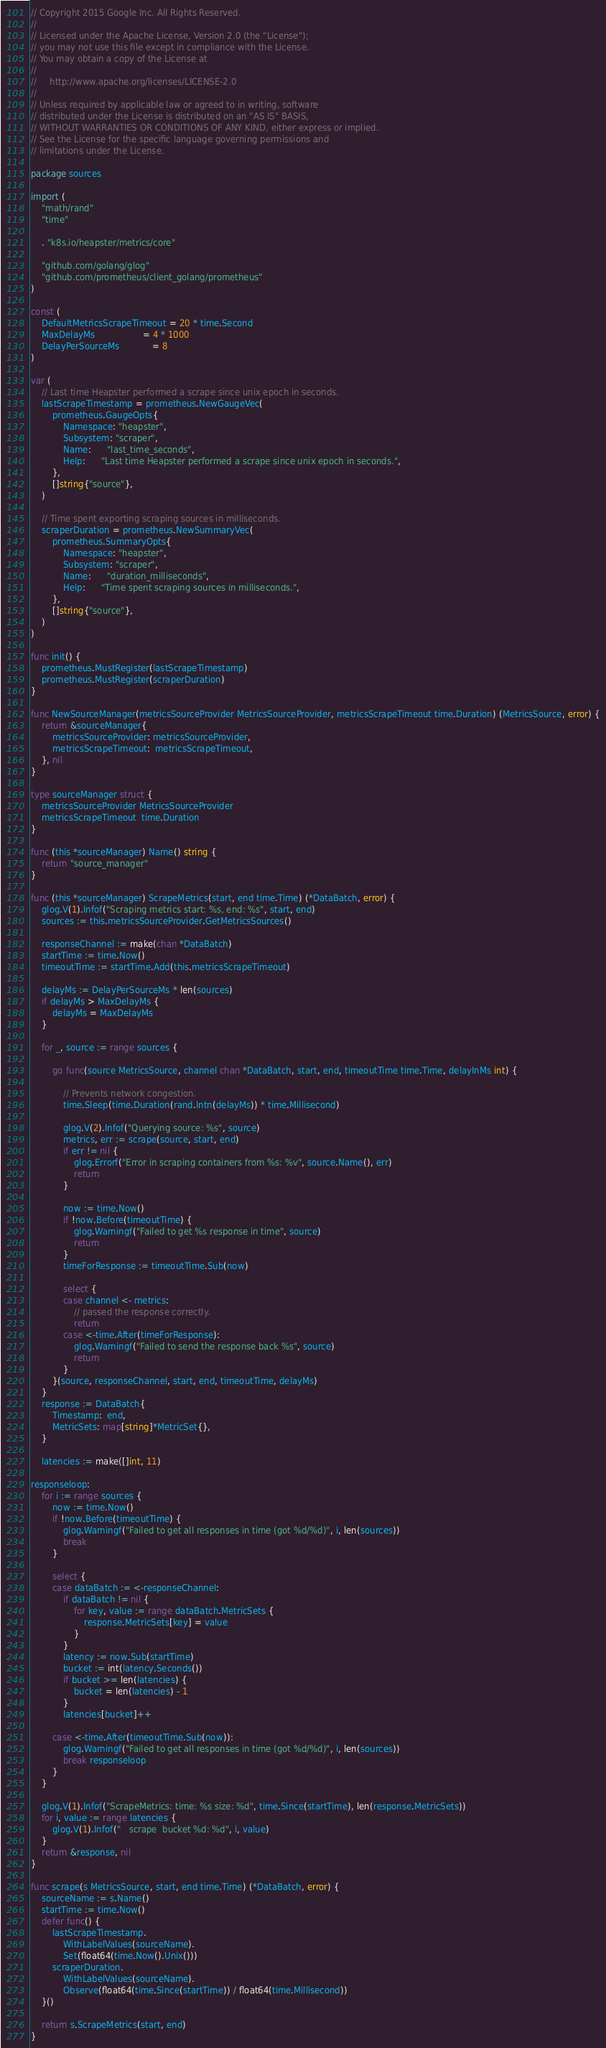Convert code to text. <code><loc_0><loc_0><loc_500><loc_500><_Go_>// Copyright 2015 Google Inc. All Rights Reserved.
//
// Licensed under the Apache License, Version 2.0 (the "License");
// you may not use this file except in compliance with the License.
// You may obtain a copy of the License at
//
//     http://www.apache.org/licenses/LICENSE-2.0
//
// Unless required by applicable law or agreed to in writing, software
// distributed under the License is distributed on an "AS IS" BASIS,
// WITHOUT WARRANTIES OR CONDITIONS OF ANY KIND, either express or implied.
// See the License for the specific language governing permissions and
// limitations under the License.

package sources

import (
	"math/rand"
	"time"

	. "k8s.io/heapster/metrics/core"

	"github.com/golang/glog"
	"github.com/prometheus/client_golang/prometheus"
)

const (
	DefaultMetricsScrapeTimeout = 20 * time.Second
	MaxDelayMs                  = 4 * 1000
	DelayPerSourceMs            = 8
)

var (
	// Last time Heapster performed a scrape since unix epoch in seconds.
	lastScrapeTimestamp = prometheus.NewGaugeVec(
		prometheus.GaugeOpts{
			Namespace: "heapster",
			Subsystem: "scraper",
			Name:      "last_time_seconds",
			Help:      "Last time Heapster performed a scrape since unix epoch in seconds.",
		},
		[]string{"source"},
	)

	// Time spent exporting scraping sources in milliseconds.
	scraperDuration = prometheus.NewSummaryVec(
		prometheus.SummaryOpts{
			Namespace: "heapster",
			Subsystem: "scraper",
			Name:      "duration_milliseconds",
			Help:      "Time spent scraping sources in milliseconds.",
		},
		[]string{"source"},
	)
)

func init() {
	prometheus.MustRegister(lastScrapeTimestamp)
	prometheus.MustRegister(scraperDuration)
}

func NewSourceManager(metricsSourceProvider MetricsSourceProvider, metricsScrapeTimeout time.Duration) (MetricsSource, error) {
	return &sourceManager{
		metricsSourceProvider: metricsSourceProvider,
		metricsScrapeTimeout:  metricsScrapeTimeout,
	}, nil
}

type sourceManager struct {
	metricsSourceProvider MetricsSourceProvider
	metricsScrapeTimeout  time.Duration
}

func (this *sourceManager) Name() string {
	return "source_manager"
}

func (this *sourceManager) ScrapeMetrics(start, end time.Time) (*DataBatch, error) {
	glog.V(1).Infof("Scraping metrics start: %s, end: %s", start, end)
	sources := this.metricsSourceProvider.GetMetricsSources()

	responseChannel := make(chan *DataBatch)
	startTime := time.Now()
	timeoutTime := startTime.Add(this.metricsScrapeTimeout)

	delayMs := DelayPerSourceMs * len(sources)
	if delayMs > MaxDelayMs {
		delayMs = MaxDelayMs
	}

	for _, source := range sources {

		go func(source MetricsSource, channel chan *DataBatch, start, end, timeoutTime time.Time, delayInMs int) {

			// Prevents network congestion.
			time.Sleep(time.Duration(rand.Intn(delayMs)) * time.Millisecond)

			glog.V(2).Infof("Querying source: %s", source)
			metrics, err := scrape(source, start, end)
			if err != nil {
				glog.Errorf("Error in scraping containers from %s: %v", source.Name(), err)
				return
			}

			now := time.Now()
			if !now.Before(timeoutTime) {
				glog.Warningf("Failed to get %s response in time", source)
				return
			}
			timeForResponse := timeoutTime.Sub(now)

			select {
			case channel <- metrics:
				// passed the response correctly.
				return
			case <-time.After(timeForResponse):
				glog.Warningf("Failed to send the response back %s", source)
				return
			}
		}(source, responseChannel, start, end, timeoutTime, delayMs)
	}
	response := DataBatch{
		Timestamp:  end,
		MetricSets: map[string]*MetricSet{},
	}

	latencies := make([]int, 11)

responseloop:
	for i := range sources {
		now := time.Now()
		if !now.Before(timeoutTime) {
			glog.Warningf("Failed to get all responses in time (got %d/%d)", i, len(sources))
			break
		}

		select {
		case dataBatch := <-responseChannel:
			if dataBatch != nil {
				for key, value := range dataBatch.MetricSets {
					response.MetricSets[key] = value
				}
			}
			latency := now.Sub(startTime)
			bucket := int(latency.Seconds())
			if bucket >= len(latencies) {
				bucket = len(latencies) - 1
			}
			latencies[bucket]++

		case <-time.After(timeoutTime.Sub(now)):
			glog.Warningf("Failed to get all responses in time (got %d/%d)", i, len(sources))
			break responseloop
		}
	}

	glog.V(1).Infof("ScrapeMetrics: time: %s size: %d", time.Since(startTime), len(response.MetricSets))
	for i, value := range latencies {
		glog.V(1).Infof("   scrape  bucket %d: %d", i, value)
	}
	return &response, nil
}

func scrape(s MetricsSource, start, end time.Time) (*DataBatch, error) {
	sourceName := s.Name()
	startTime := time.Now()
	defer func() {
		lastScrapeTimestamp.
			WithLabelValues(sourceName).
			Set(float64(time.Now().Unix()))
		scraperDuration.
			WithLabelValues(sourceName).
			Observe(float64(time.Since(startTime)) / float64(time.Millisecond))
	}()

	return s.ScrapeMetrics(start, end)
}
</code> 